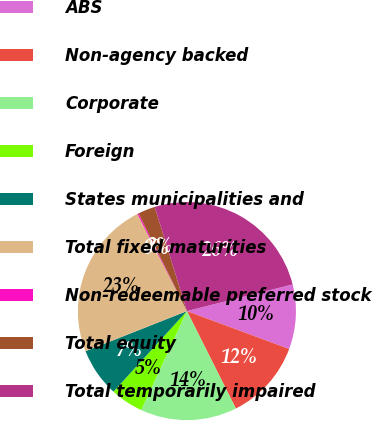Convert chart. <chart><loc_0><loc_0><loc_500><loc_500><pie_chart><fcel>ABS<fcel>Non-agency backed<fcel>Corporate<fcel>Foreign<fcel>States municipalities and<fcel>Total fixed maturities<fcel>Non-redeemable preferred stock<fcel>Total equity<fcel>Total temporarily impaired<nl><fcel>9.59%<fcel>11.94%<fcel>14.29%<fcel>4.89%<fcel>7.24%<fcel>23.49%<fcel>0.19%<fcel>2.54%<fcel>25.84%<nl></chart> 